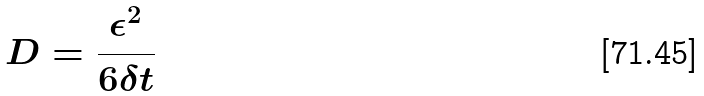Convert formula to latex. <formula><loc_0><loc_0><loc_500><loc_500>D = \frac { \epsilon ^ { 2 } } { 6 \delta t }</formula> 